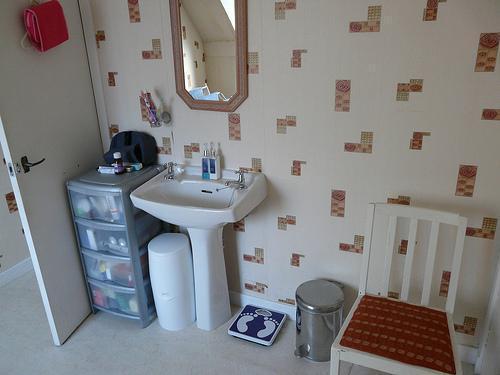How many chairs are shown?
Give a very brief answer. 1. How many square blotches are in between the bars of the chair?
Give a very brief answer. 3. 